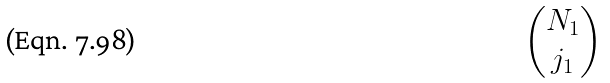Convert formula to latex. <formula><loc_0><loc_0><loc_500><loc_500>\begin{pmatrix} N _ { 1 } \\ j _ { 1 } \end{pmatrix}</formula> 